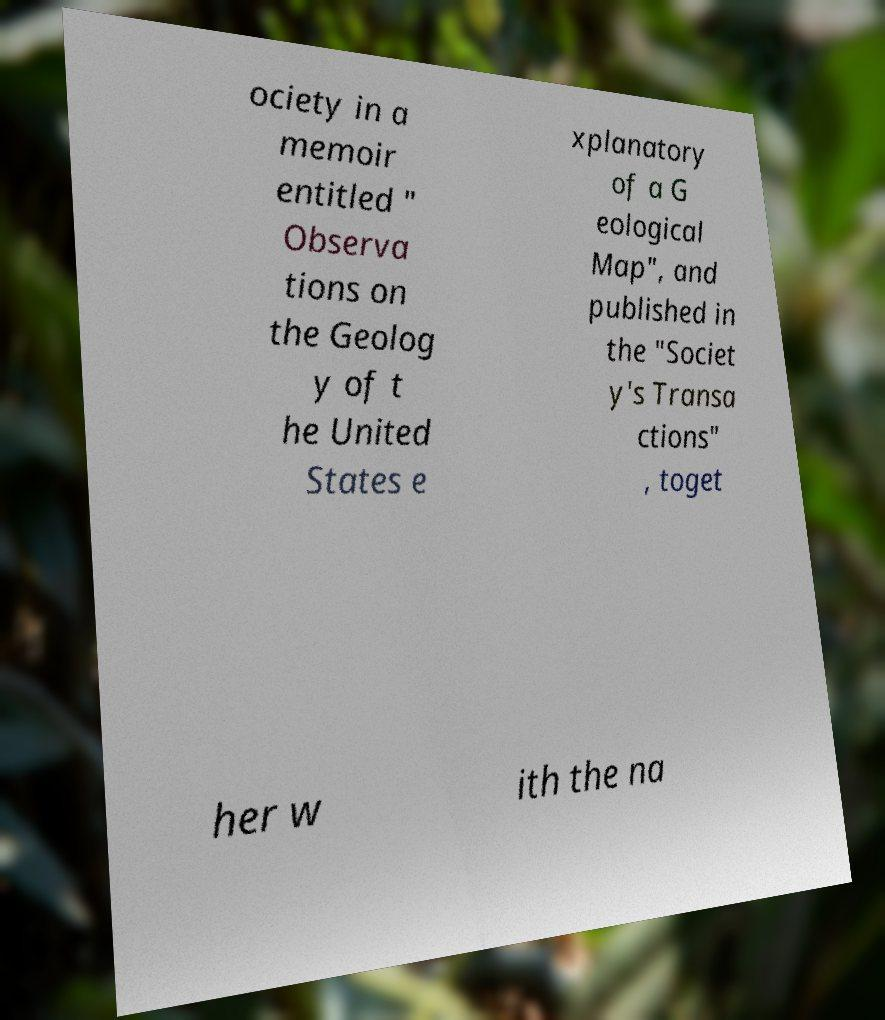Please identify and transcribe the text found in this image. ociety in a memoir entitled " Observa tions on the Geolog y of t he United States e xplanatory of a G eological Map", and published in the "Societ y's Transa ctions" , toget her w ith the na 